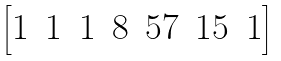Convert formula to latex. <formula><loc_0><loc_0><loc_500><loc_500>\left [ \begin{matrix} 1 & 1 & 1 & 8 & 5 7 & 1 5 & 1 \end{matrix} \right ]</formula> 